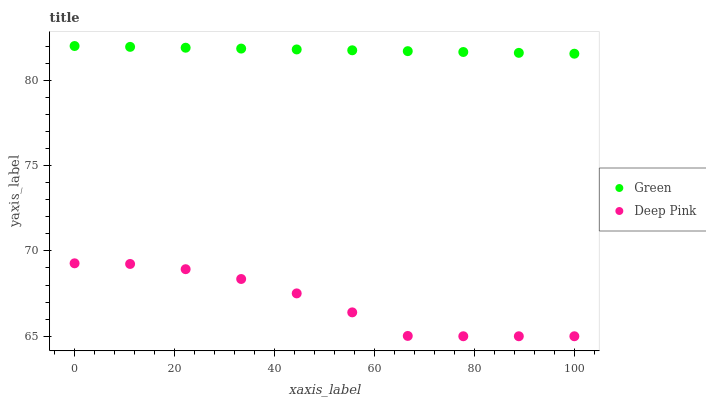Does Deep Pink have the minimum area under the curve?
Answer yes or no. Yes. Does Green have the maximum area under the curve?
Answer yes or no. Yes. Does Green have the minimum area under the curve?
Answer yes or no. No. Is Green the smoothest?
Answer yes or no. Yes. Is Deep Pink the roughest?
Answer yes or no. Yes. Is Green the roughest?
Answer yes or no. No. Does Deep Pink have the lowest value?
Answer yes or no. Yes. Does Green have the lowest value?
Answer yes or no. No. Does Green have the highest value?
Answer yes or no. Yes. Is Deep Pink less than Green?
Answer yes or no. Yes. Is Green greater than Deep Pink?
Answer yes or no. Yes. Does Deep Pink intersect Green?
Answer yes or no. No. 